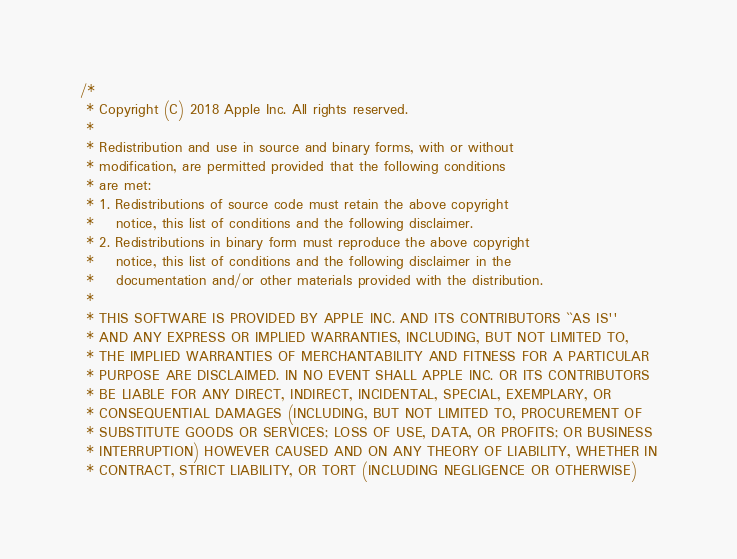Convert code to text. <code><loc_0><loc_0><loc_500><loc_500><_ObjectiveC_>/*
 * Copyright (C) 2018 Apple Inc. All rights reserved.
 *
 * Redistribution and use in source and binary forms, with or without
 * modification, are permitted provided that the following conditions
 * are met:
 * 1. Redistributions of source code must retain the above copyright
 *    notice, this list of conditions and the following disclaimer.
 * 2. Redistributions in binary form must reproduce the above copyright
 *    notice, this list of conditions and the following disclaimer in the
 *    documentation and/or other materials provided with the distribution.
 *
 * THIS SOFTWARE IS PROVIDED BY APPLE INC. AND ITS CONTRIBUTORS ``AS IS''
 * AND ANY EXPRESS OR IMPLIED WARRANTIES, INCLUDING, BUT NOT LIMITED TO,
 * THE IMPLIED WARRANTIES OF MERCHANTABILITY AND FITNESS FOR A PARTICULAR
 * PURPOSE ARE DISCLAIMED. IN NO EVENT SHALL APPLE INC. OR ITS CONTRIBUTORS
 * BE LIABLE FOR ANY DIRECT, INDIRECT, INCIDENTAL, SPECIAL, EXEMPLARY, OR
 * CONSEQUENTIAL DAMAGES (INCLUDING, BUT NOT LIMITED TO, PROCUREMENT OF
 * SUBSTITUTE GOODS OR SERVICES; LOSS OF USE, DATA, OR PROFITS; OR BUSINESS
 * INTERRUPTION) HOWEVER CAUSED AND ON ANY THEORY OF LIABILITY, WHETHER IN
 * CONTRACT, STRICT LIABILITY, OR TORT (INCLUDING NEGLIGENCE OR OTHERWISE)</code> 